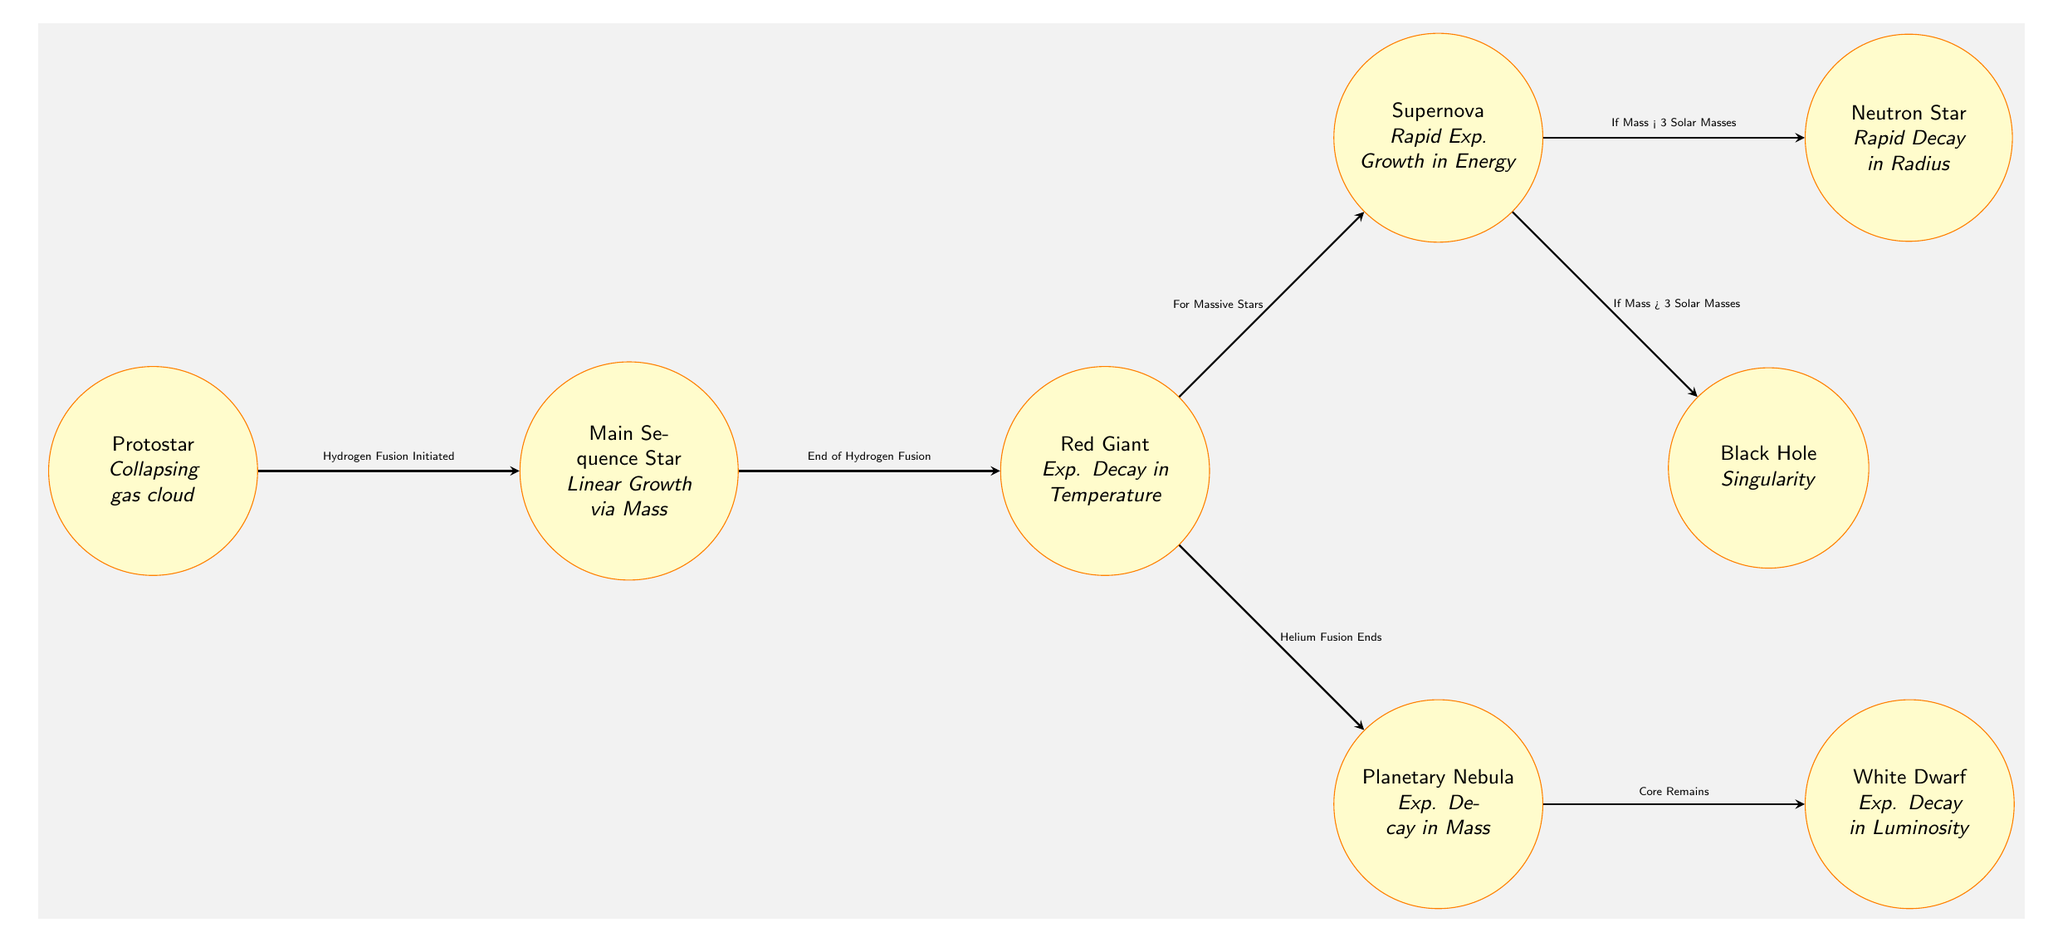What is the first stage in stellar evolution? The diagram identifies the first stage as "Protostar." This is indicated by the position of the "Protostar" node on the far left, representing the initial phase of a star's formation process.
Answer: Protostar What type of star follows the Main Sequence Star in stellar evolution? The flow in the diagram leads directly from the "Main Sequence Star" node to the "Red Giant" node, showing that the Red Giant is the stage that follows the Main Sequence Star.
Answer: Red Giant How many key stages are there in the stellar evolution process represented? The diagram displays a total of seven nodes, which represent the key stages of stellar evolution. These include Protostar, Main Sequence Star, Red Giant, Planetary Nebula, White Dwarf, Supernova, Neutron Star, and Black Hole.
Answer: Seven What process initiates the transition from the Protostar to the Main Sequence Star? The diagram includes an arrow from the "Protostar" to the "Main Sequence Star" labeled "Hydrogen Fusion Initiated," indicating that this fusion process marks the transition between these two stages.
Answer: Hydrogen Fusion Initiated If a star is massive, what happens after it becomes a Red Giant? The diagram assists the reasoning that if a star is classified as massive, it transitions from the "Red Giant" to the "Supernova," as indicated by the directed arrow and the associated text in the diagram.
Answer: Supernova During which phase does a star experience a rapid exponential growth in energy? The diagram indicates that the "Supernova" stage is characterized by rapid exponential growth in energy, as noted in the node's description.
Answer: Supernova What is the fate of a star with a mass greater than 3 solar masses after a Supernova? Based on the diagram, stars with a mass greater than 3 solar masses transition to a "Black Hole" after the Supernova, as indicated by the arrow and the text next to the arrow.
Answer: Black Hole Which node represents the phase after helium fusion ends? The arrow leading from the "Red Giant" node to the "Planetary Nebula" node is labeled "Helium Fusion Ends," signaling that the Planetary Nebula is the phase that occurs after helium fusion concludes.
Answer: Planetary Nebula What is the behavior of the White Dwarf in terms of luminosity? The diagram notes that the "White Dwarf" experiences exponential decay in luminosity, indicated by the text associated with this node.
Answer: Exp. Decay in Luminosity 